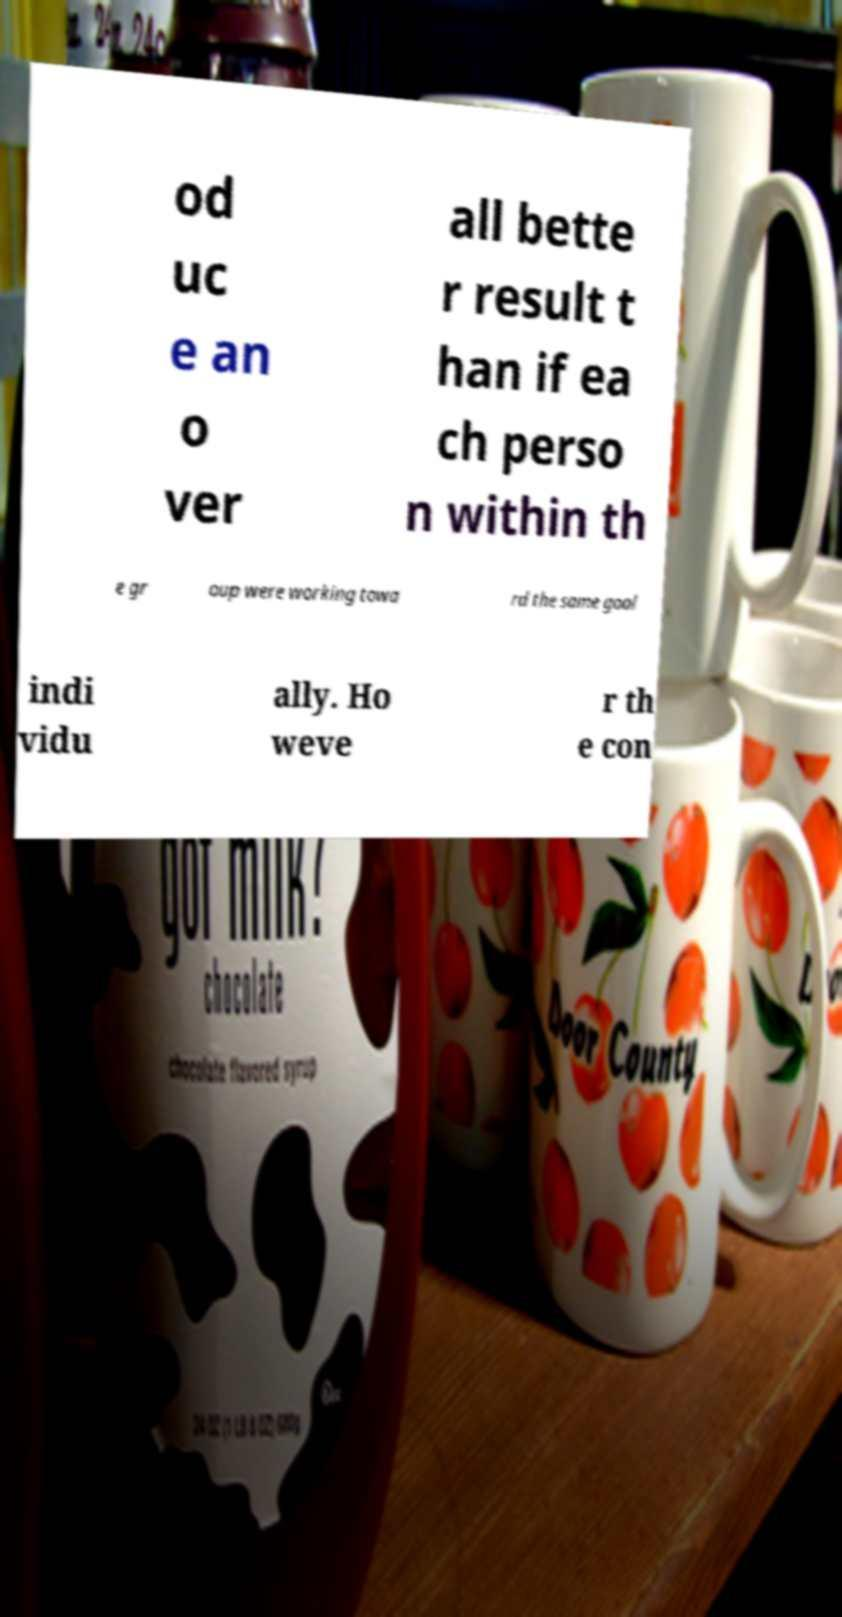Please read and relay the text visible in this image. What does it say? od uc e an o ver all bette r result t han if ea ch perso n within th e gr oup were working towa rd the same goal indi vidu ally. Ho weve r th e con 